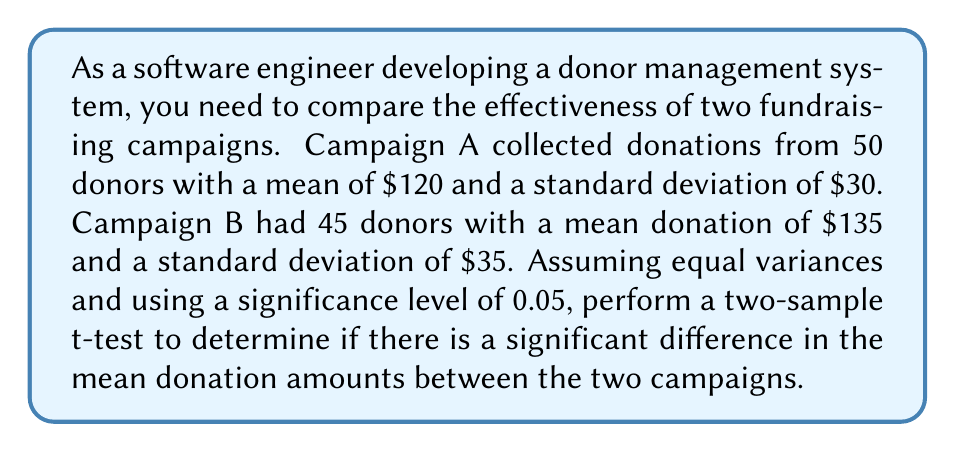What is the answer to this math problem? 1. State the hypotheses:
   $H_0: \mu_A = \mu_B$ (null hypothesis)
   $H_a: \mu_A \neq \mu_B$ (alternative hypothesis)

2. Calculate the pooled standard deviation:
   $s_p = \sqrt{\frac{(n_A - 1)s_A^2 + (n_B - 1)s_B^2}{n_A + n_B - 2}}$
   $s_p = \sqrt{\frac{(50 - 1)(30^2) + (45 - 1)(35^2)}{50 + 45 - 2}} = 32.41$

3. Calculate the t-statistic:
   $t = \frac{\bar{x}_A - \bar{x}_B}{s_p\sqrt{\frac{1}{n_A} + \frac{1}{n_B}}}$
   $t = \frac{120 - 135}{32.41\sqrt{\frac{1}{50} + \frac{1}{45}}} = -2.28$

4. Determine the degrees of freedom:
   $df = n_A + n_B - 2 = 50 + 45 - 2 = 93$

5. Find the critical t-value for a two-tailed test with α = 0.05 and df = 93:
   $t_{critical} = \pm 1.986$ (from t-distribution table)

6. Compare the calculated t-statistic with the critical t-value:
   $|-2.28| > 1.986$

7. Calculate the p-value:
   $p-value = 0.0249$ (using t-distribution calculator)

8. Make a decision:
   Since $|t| > t_{critical}$ and $p-value < 0.05$, we reject the null hypothesis.
Answer: Reject $H_0$; significant difference in mean donation amounts (p = 0.0249) 